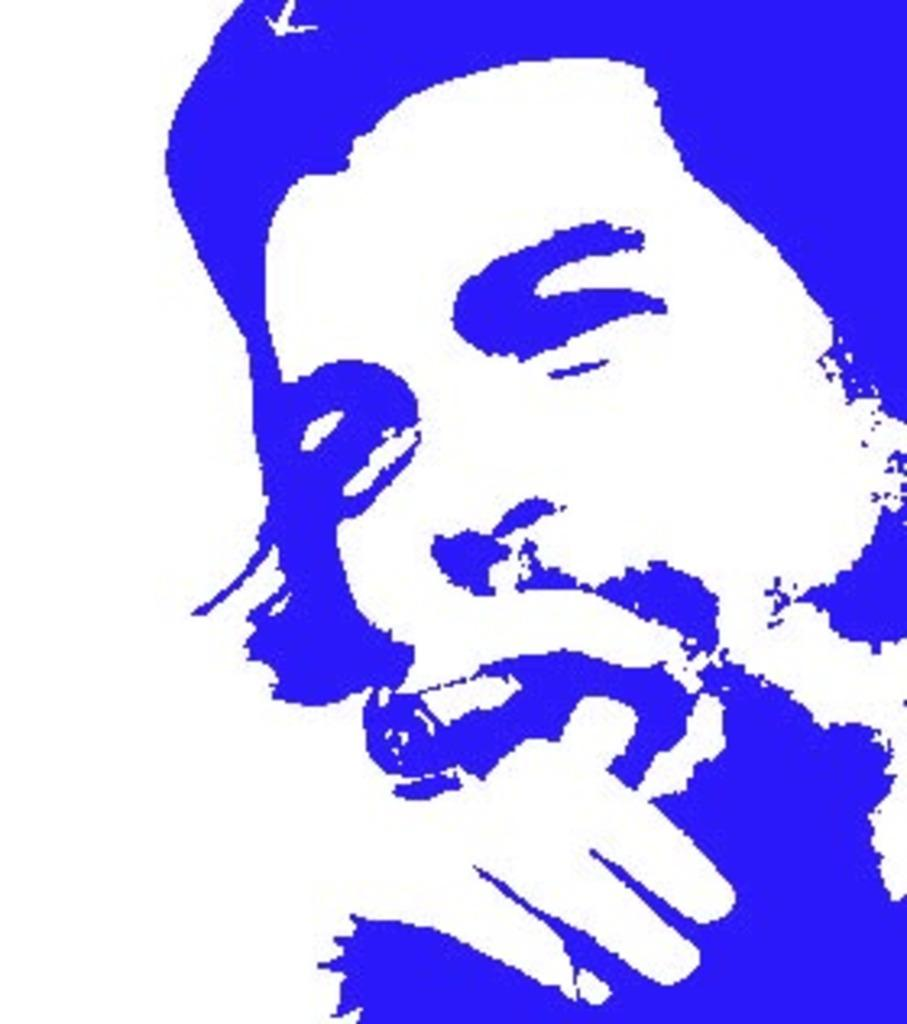What is the main subject of the image? The main subject of the image is a person's edited picture. What color is the background of the image? The background of the image is white. How many books are on the person's memory in the image? There are no books or references to memory in the image; it only features a person's edited picture with a white background. 